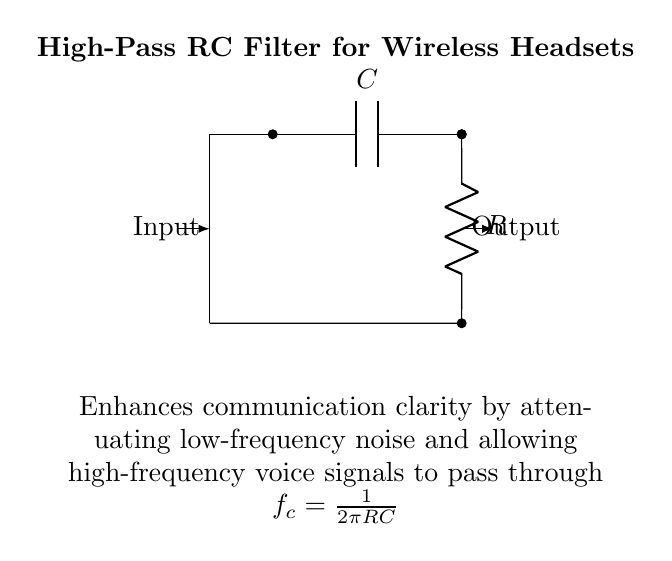What type of filter is this circuit? The circuit is a high-pass filter, which allows high-frequency signals to pass while attenuating low-frequency signals. This can be determined by the arrangement of the resistor and capacitor as shown in the circuit.
Answer: High-pass filter What components are used in this circuit? The circuit consists of a capacitor and a resistor. They are the essential components that determine the function of the filter. The labels in the circuit diagram clearly identify these components as C and R.
Answer: Capacitor and resistor What is the cutoff frequency formula for this circuit? The cutoff frequency formula is given as f_c = 1 / (2πRC). This formula is provided in the diagram and is crucial for understanding how the filter operates.
Answer: f_c = 1 / (2πRC) Which signal flows from input to output? The high-frequency signals flow from the input to the output. The design of the high-pass filter is specifically to pass these signals while blocking lower frequencies.
Answer: High-frequency signals What does this filter enhance in wireless headsets? This filter enhances communication clarity. It helps by reducing low-frequency noise and allowing clearer voice signals, making it beneficial for use in wireless headsets during matches.
Answer: Communication clarity How do R and C affect the cutoff frequency? The values of the resistor (R) and capacitor (C) inversely affect the cutoff frequency. Increasing either component's value will result in a lower cutoff frequency, and decreasing them will raise the cutoff frequency. This relationship is derived from the cutoff frequency formula mentioned earlier.
Answer: They inversely affect the cutoff frequency 